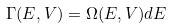Convert formula to latex. <formula><loc_0><loc_0><loc_500><loc_500>\Gamma ( E , V ) = \Omega ( E , V ) d E</formula> 